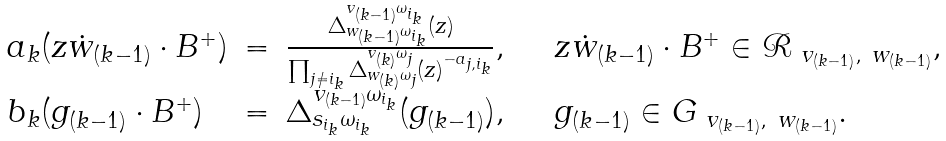Convert formula to latex. <formula><loc_0><loc_0><loc_500><loc_500>\begin{array} { l c l l } a _ { k } ( z \dot { w } _ { ( k - 1 ) } \cdot B ^ { + } ) & = & \frac { \Delta _ { w _ { ( k - 1 ) } \omega _ { i _ { k } } } ^ { v _ { ( k - 1 ) } \omega _ { i _ { k } } } ( z ) } { \prod _ { j \not = i _ { k } } \Delta _ { w _ { ( k ) } \omega _ { j } } ^ { v _ { ( k ) } \omega _ { j } } ( z ) ^ { - a _ { j , i _ { k } } } } , & \quad z \dot { w } _ { ( k - 1 ) } \cdot B ^ { + } \in \mathcal { R } _ { \ v _ { ( k - 1 ) } , \ w _ { ( k - 1 ) } } , \\ b _ { k } ( g _ { ( k - 1 ) } \cdot B ^ { + } ) & = & \Delta _ { s _ { i _ { k } } \omega _ { i _ { k } } } ^ { v _ { ( k - 1 ) } \omega _ { i _ { k } } } ( g _ { ( k - 1 ) } ) , & \quad g _ { ( k - 1 ) } \in G _ { \ v _ { ( k - 1 ) } , \ w _ { ( k - 1 ) } } . \end{array}</formula> 